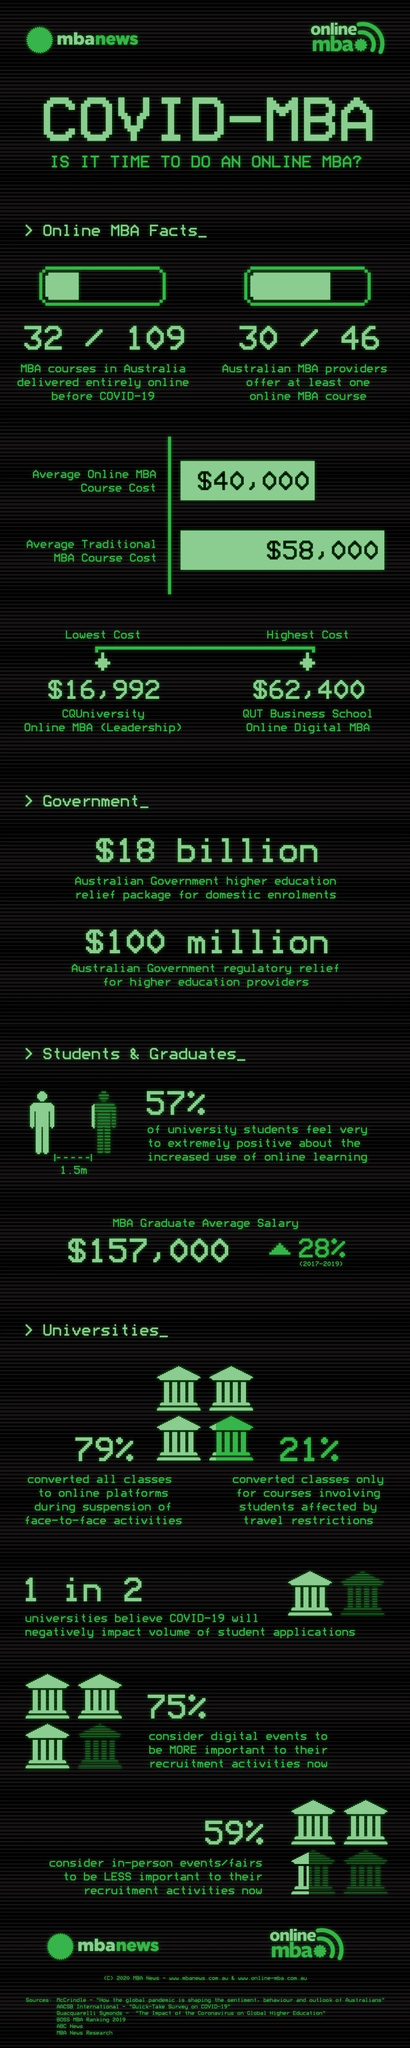What is the difference between the highest cost and lowest cost for an online MBA course?
Answer the question with a short phrase. $45,408 Out of 109, how many MBA courses in Australia are not delivered entirely online before Covid-19? 77 Out of 2, how many universities believe Covid-19 will negatively impact the volume of student applications? 1 Out of 46, how many Australian MBA providers offer at least one online MBA course? 30 